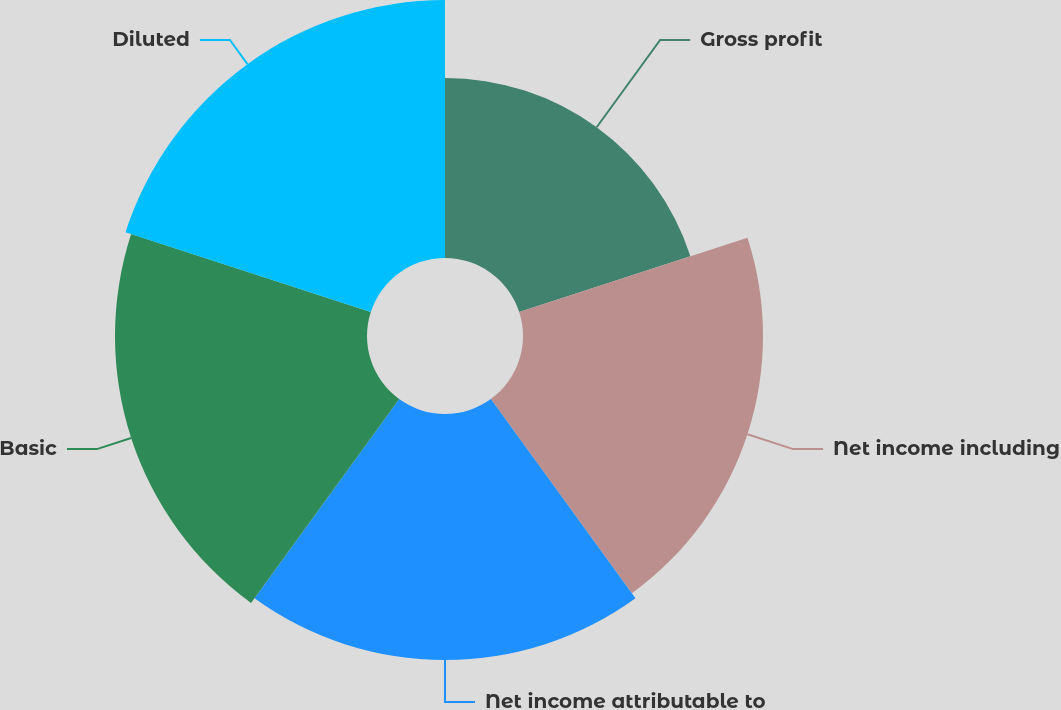Convert chart. <chart><loc_0><loc_0><loc_500><loc_500><pie_chart><fcel>Gross profit<fcel>Net income including<fcel>Net income attributable to<fcel>Basic<fcel>Diluted<nl><fcel>15.31%<fcel>20.41%<fcel>20.92%<fcel>21.43%<fcel>21.94%<nl></chart> 